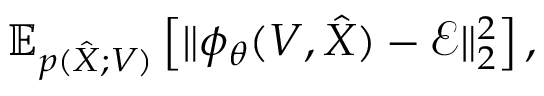<formula> <loc_0><loc_0><loc_500><loc_500>\mathbb { E } _ { p ( \hat { X } ; V ) } \left [ \| \phi _ { \theta } ( { V } , \hat { X } ) - { \mathcal { E } } \| _ { 2 } ^ { 2 } \right ] ,</formula> 